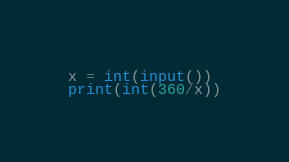<code> <loc_0><loc_0><loc_500><loc_500><_Python_>x = int(input())
print(int(360/x))</code> 